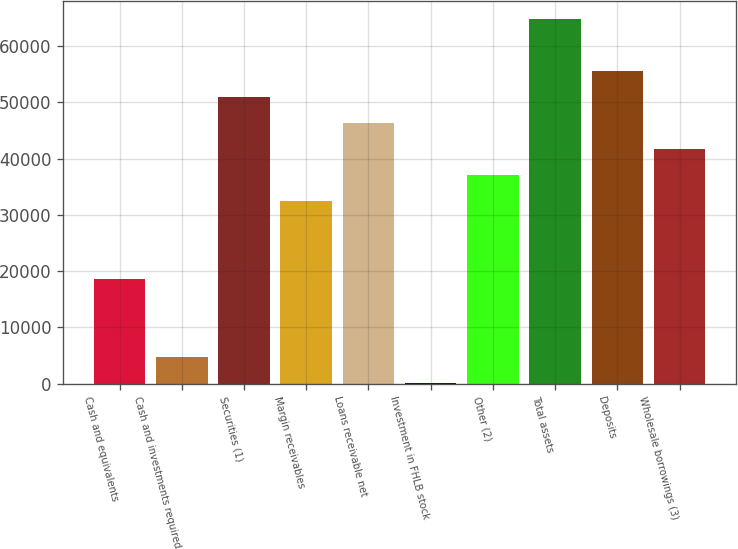<chart> <loc_0><loc_0><loc_500><loc_500><bar_chart><fcel>Cash and equivalents<fcel>Cash and investments required<fcel>Securities (1)<fcel>Margin receivables<fcel>Loans receivable net<fcel>Investment in FHLB stock<fcel>Other (2)<fcel>Total assets<fcel>Deposits<fcel>Wholesale borrowings (3)<nl><fcel>18647.8<fcel>4785.26<fcel>50993.9<fcel>32510.4<fcel>46373<fcel>164.4<fcel>37131.3<fcel>64856.4<fcel>55614.7<fcel>41752.1<nl></chart> 